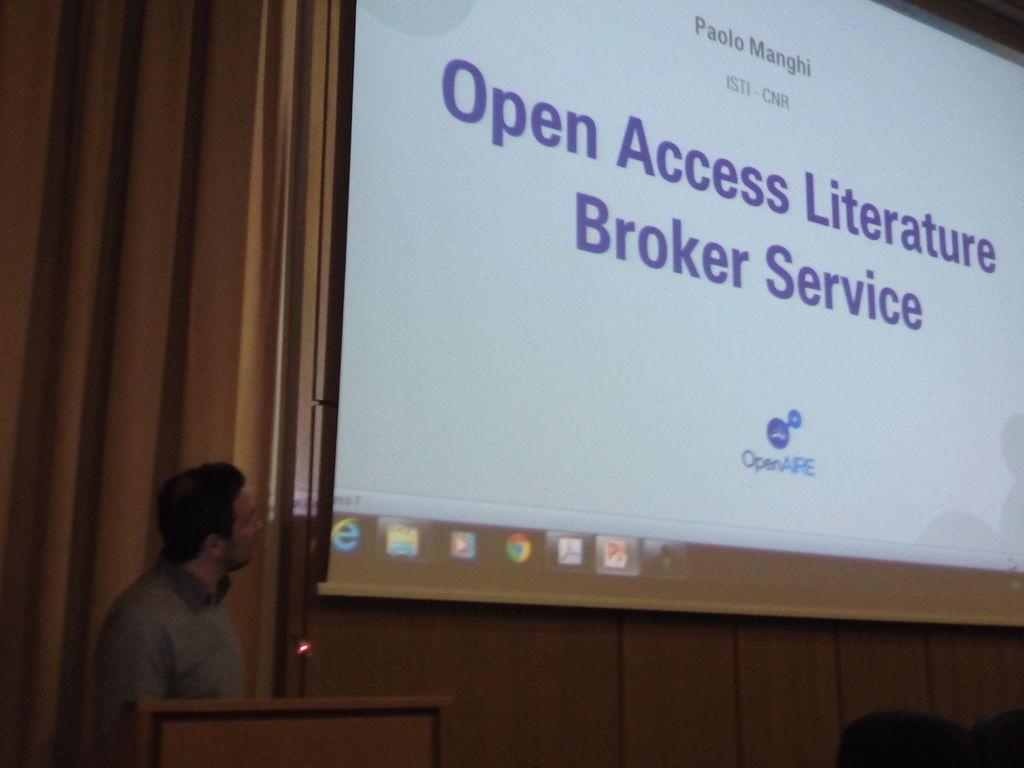Could you give a brief overview of what you see in this image? In this picture we can see a man standing here, there is a speech desk here, on the right side we can see a projector screen, we can see presentation here. 